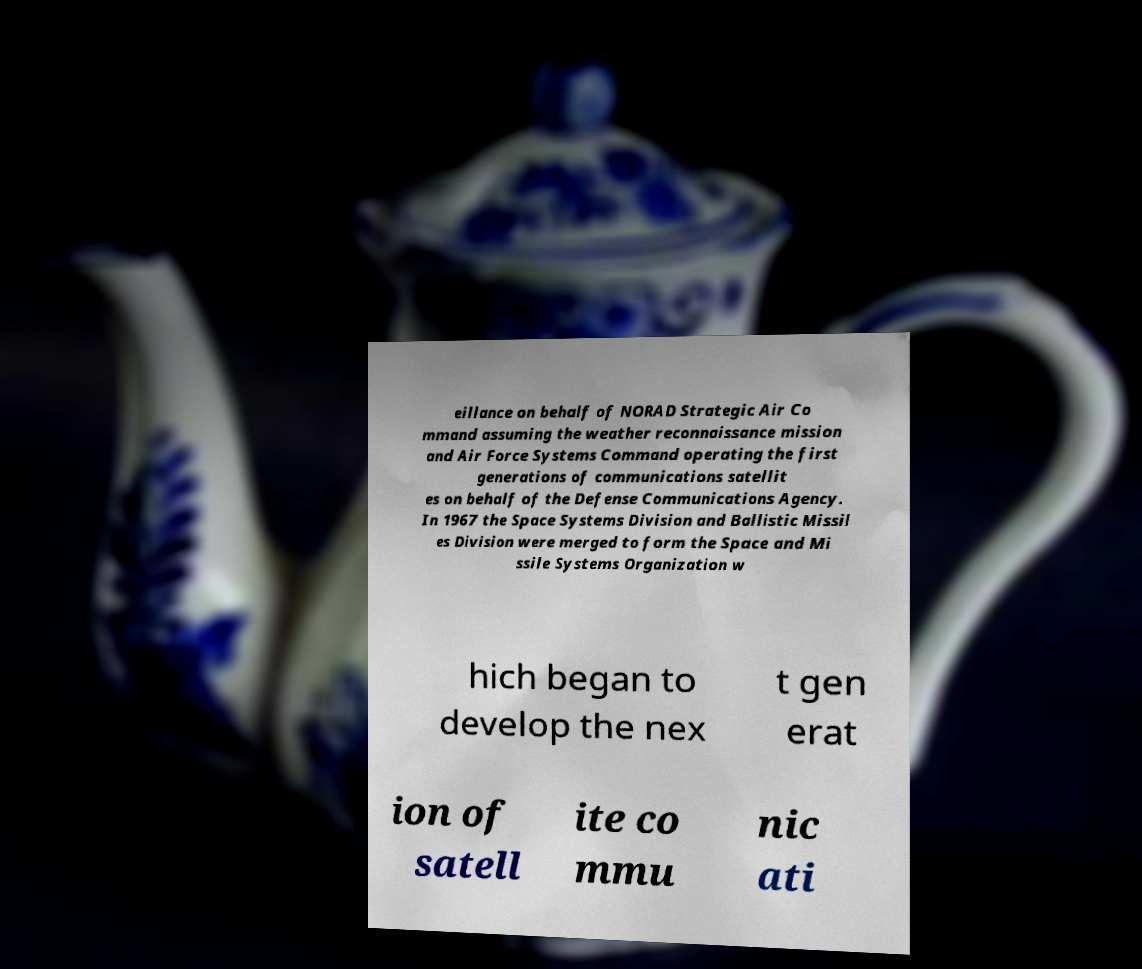Could you assist in decoding the text presented in this image and type it out clearly? eillance on behalf of NORAD Strategic Air Co mmand assuming the weather reconnaissance mission and Air Force Systems Command operating the first generations of communications satellit es on behalf of the Defense Communications Agency. In 1967 the Space Systems Division and Ballistic Missil es Division were merged to form the Space and Mi ssile Systems Organization w hich began to develop the nex t gen erat ion of satell ite co mmu nic ati 